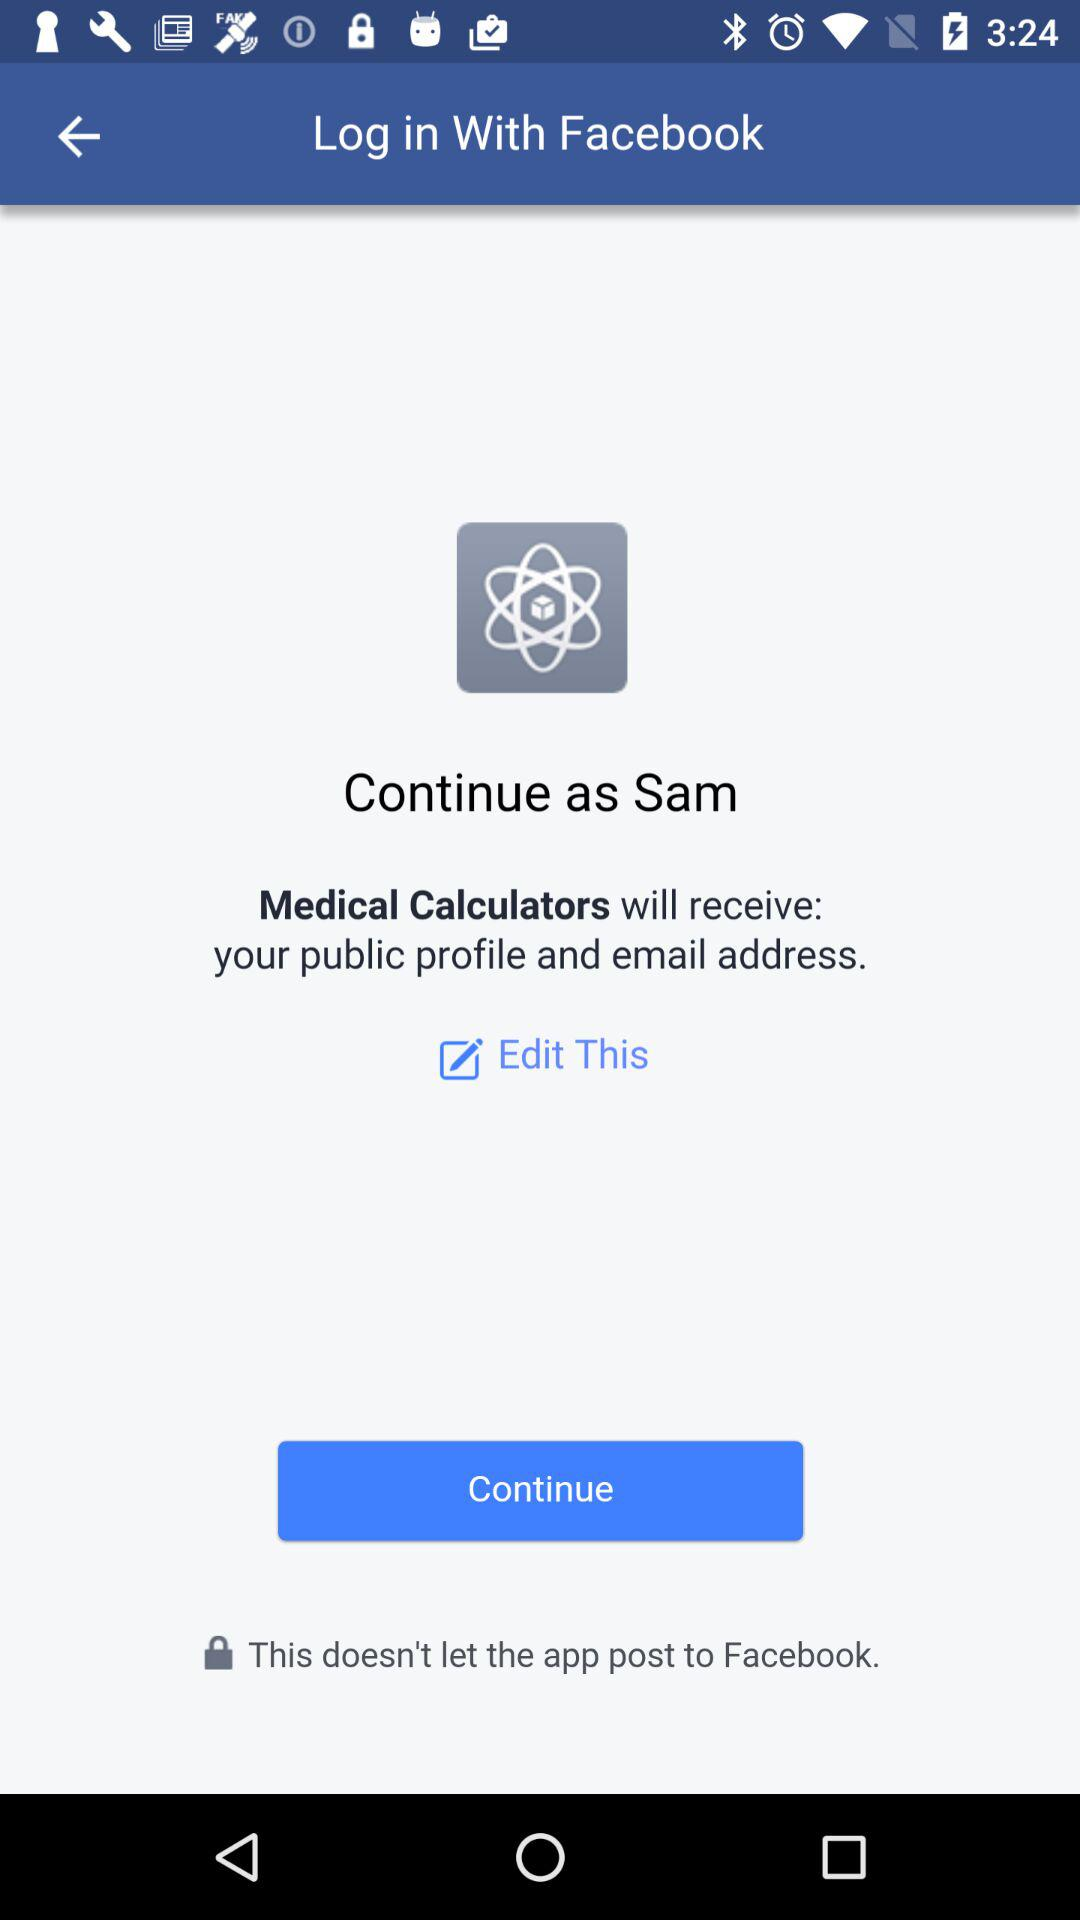What application is asking for permission? The application asking for permission is "Medical Calculators". 